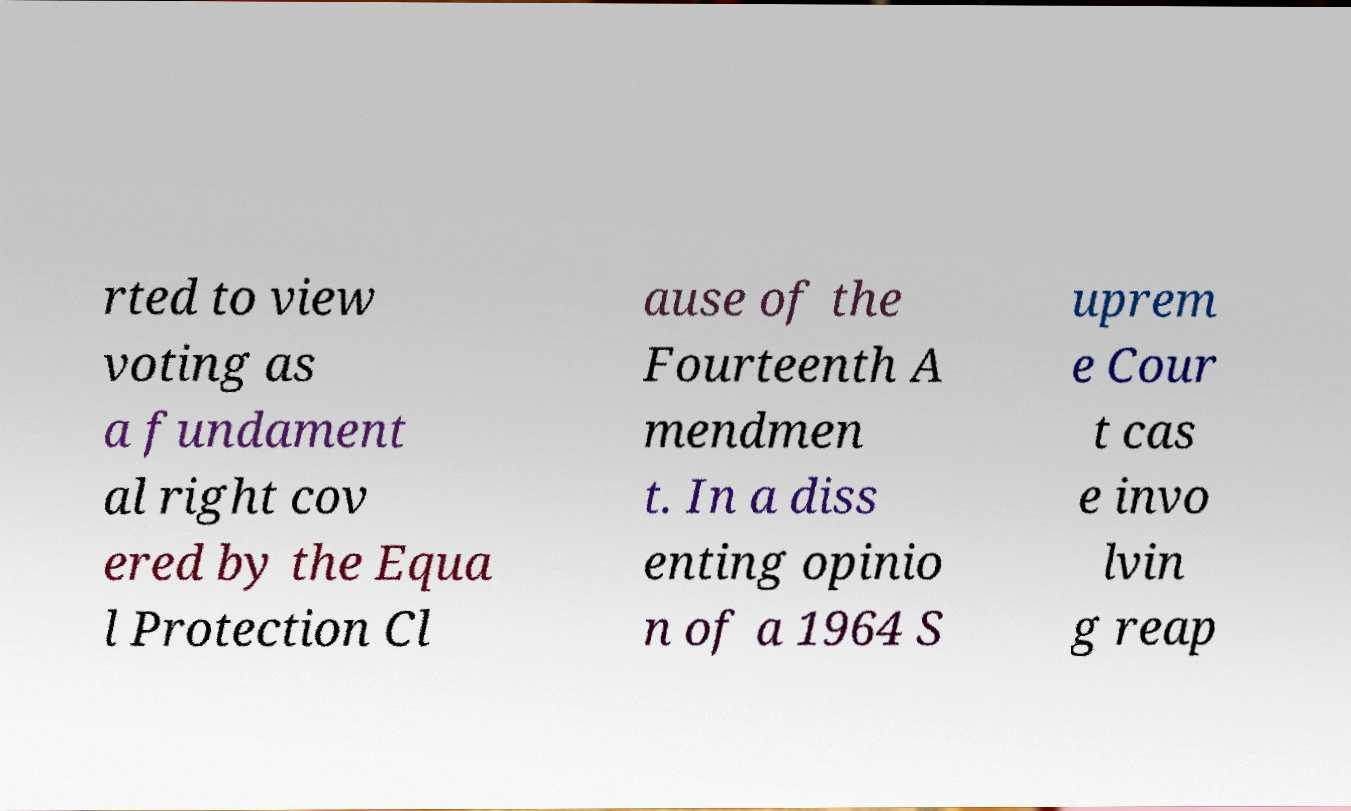There's text embedded in this image that I need extracted. Can you transcribe it verbatim? rted to view voting as a fundament al right cov ered by the Equa l Protection Cl ause of the Fourteenth A mendmen t. In a diss enting opinio n of a 1964 S uprem e Cour t cas e invo lvin g reap 